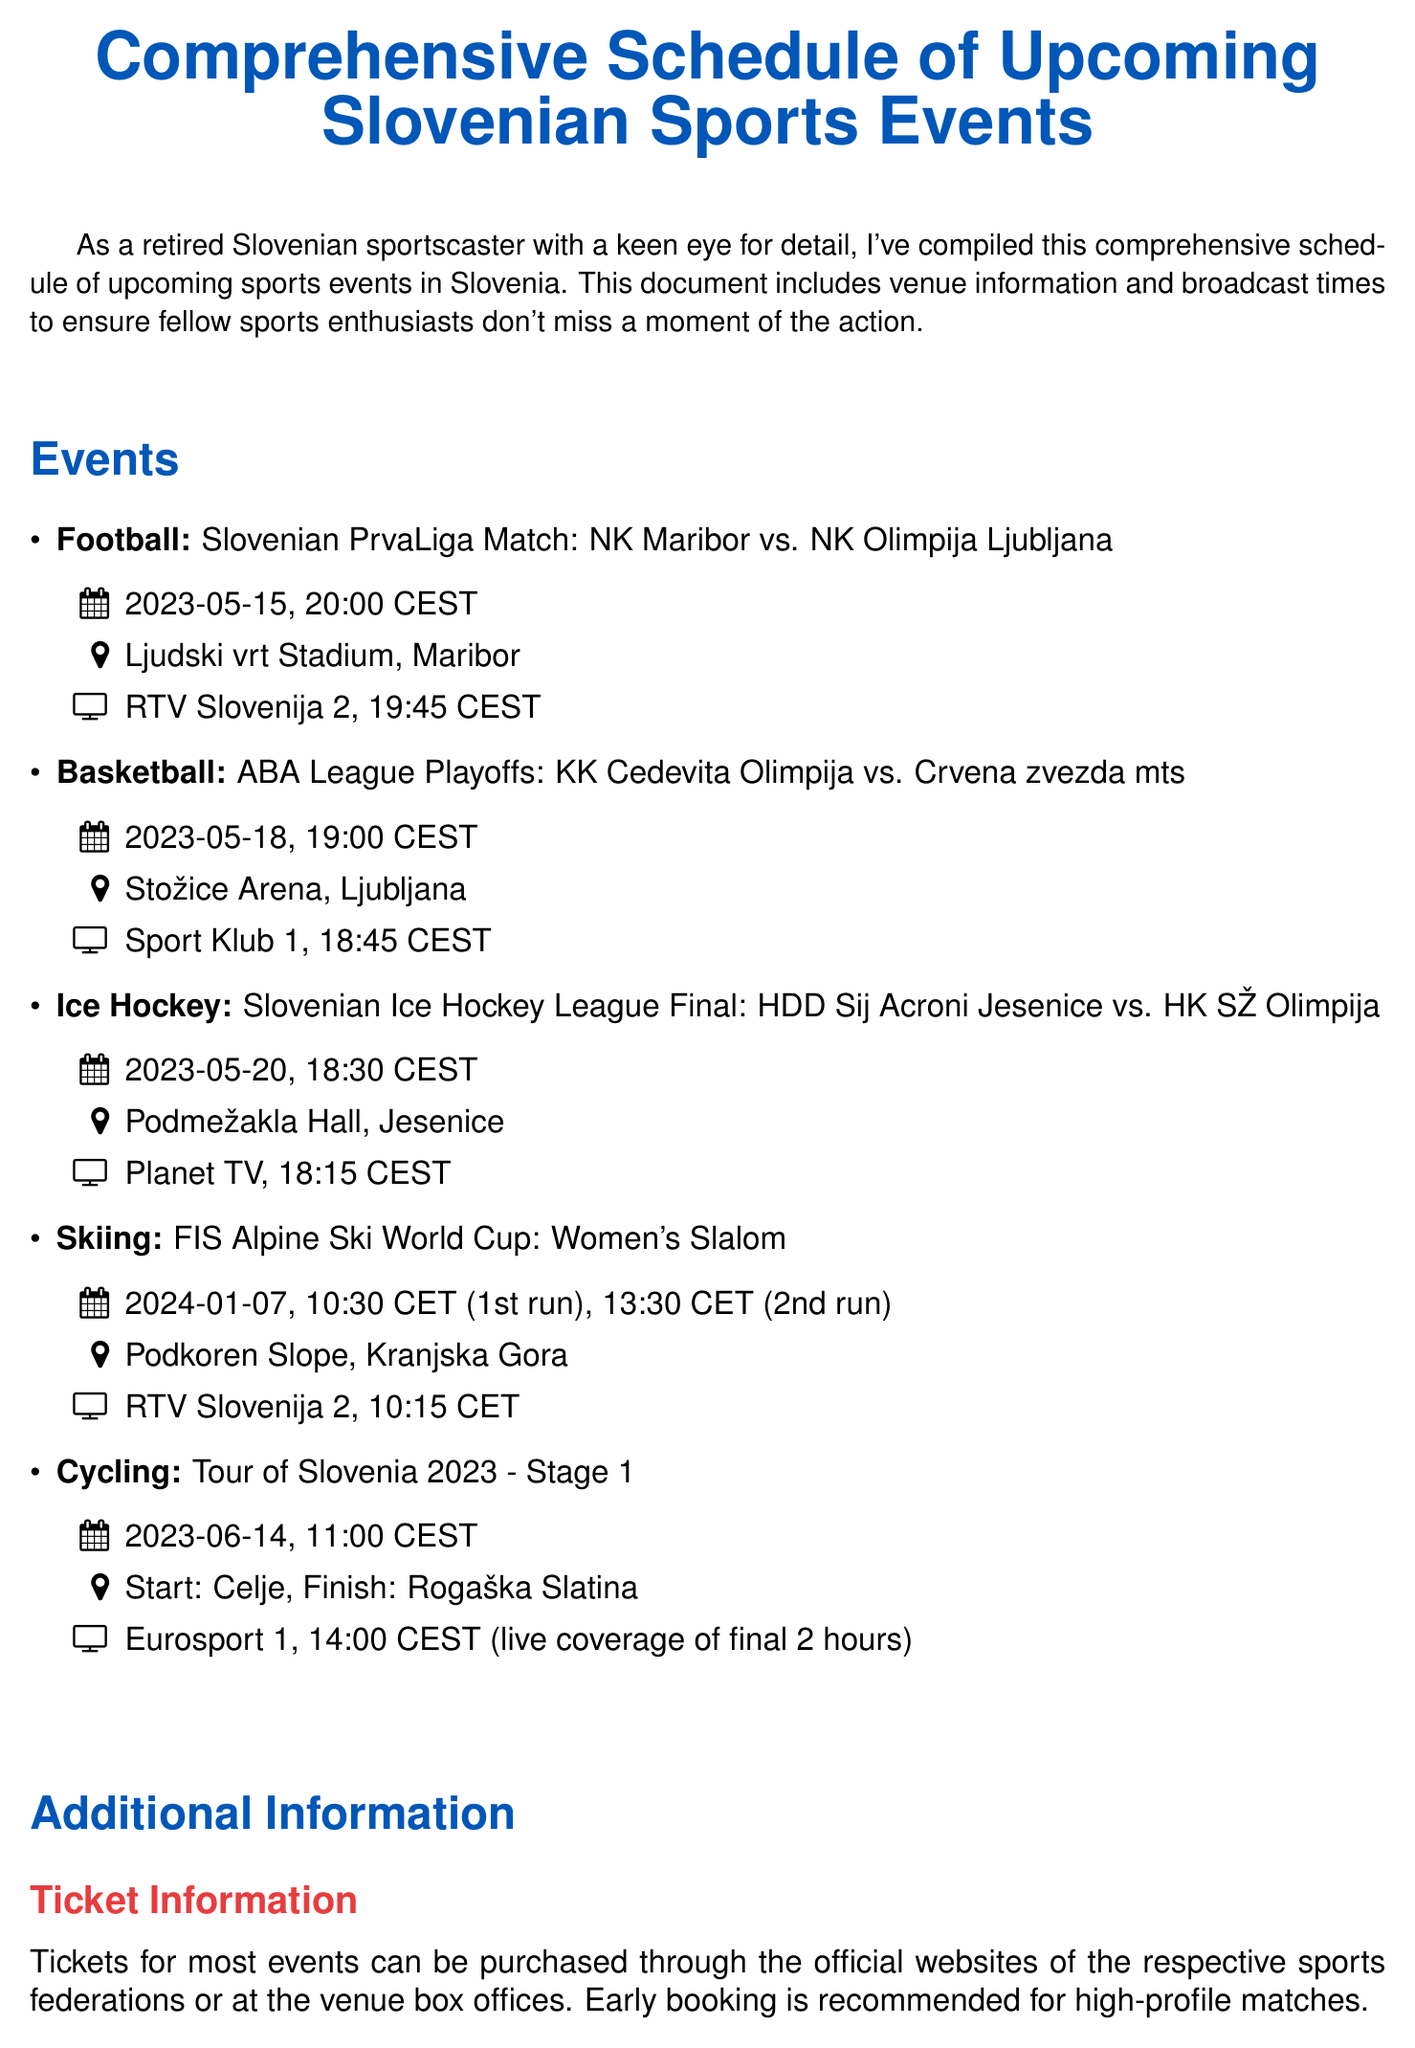What is the date of the football match? The date of the football match is explicitly stated in the document as "2023-05-15."
Answer: 2023-05-15 What is the venue for the basketball game? The venue for the basketball game is detailed in the document as "Stožice Arena, Ljubljana."
Answer: Stožice Arena, Ljubljana Which channel is broadcasting the ice hockey final? The document specifies the broadcasting channel for the ice hockey final as "Planet TV."
Answer: Planet TV What event is scheduled for January 7, 2024? The document lists "FIS Alpine Ski World Cup: Women's Slalom" as the event on that date.
Answer: FIS Alpine Ski World Cup: Women's Slalom How many events are listed in the document? The document outlines five separate events in the schedule.
Answer: 5 Why is early booking recommended for some matches? The document mentions early booking is advised due to high-profile matches, implying potential demand.
Answer: High-profile matches What is advised for avoiding traffic congestion in Ljubljana? The document recommends using "park-and-ride facilities" to avoid traffic in Ljubljana.
Answer: Park-and-ride facilities What should spectators bring for the cycling event? The document suggests spectators should bring "sun protection" for the cycling event due to summer heat.
Answer: Sun protection 